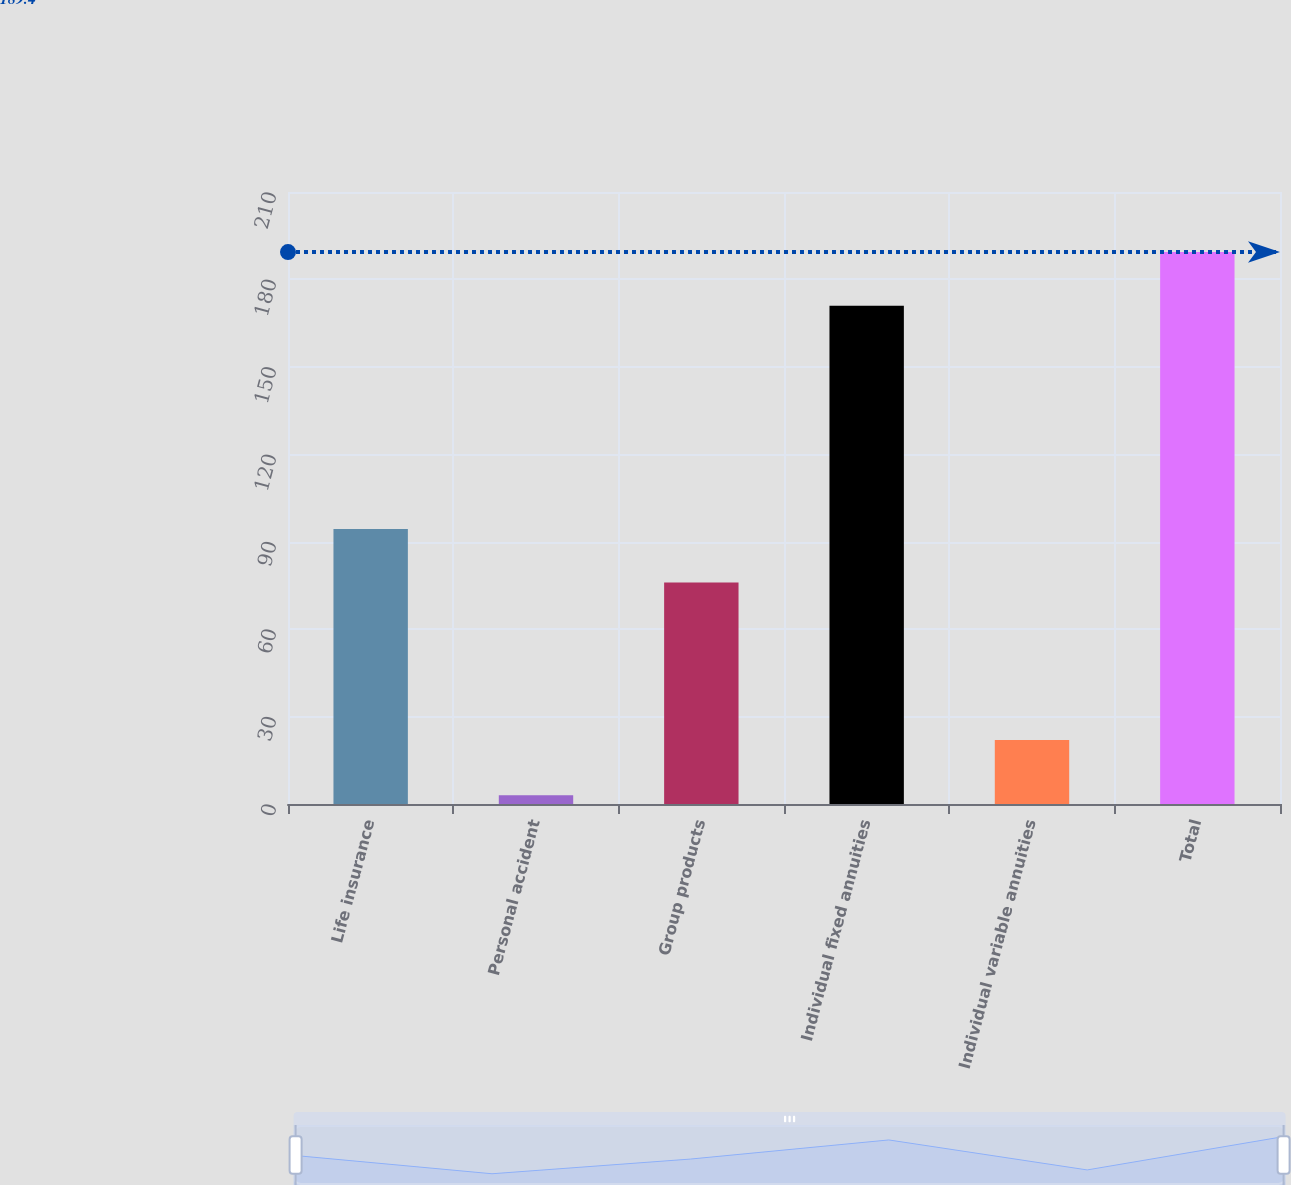Convert chart. <chart><loc_0><loc_0><loc_500><loc_500><bar_chart><fcel>Life insurance<fcel>Personal accident<fcel>Group products<fcel>Individual fixed annuities<fcel>Individual variable annuities<fcel>Total<nl><fcel>94.4<fcel>3<fcel>76<fcel>171<fcel>22<fcel>189.4<nl></chart> 